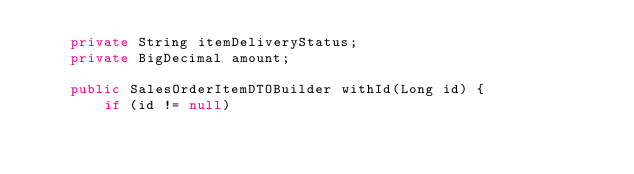Convert code to text. <code><loc_0><loc_0><loc_500><loc_500><_Java_>    private String itemDeliveryStatus;
    private BigDecimal amount;

    public SalesOrderItemDTOBuilder withId(Long id) {
        if (id != null)</code> 